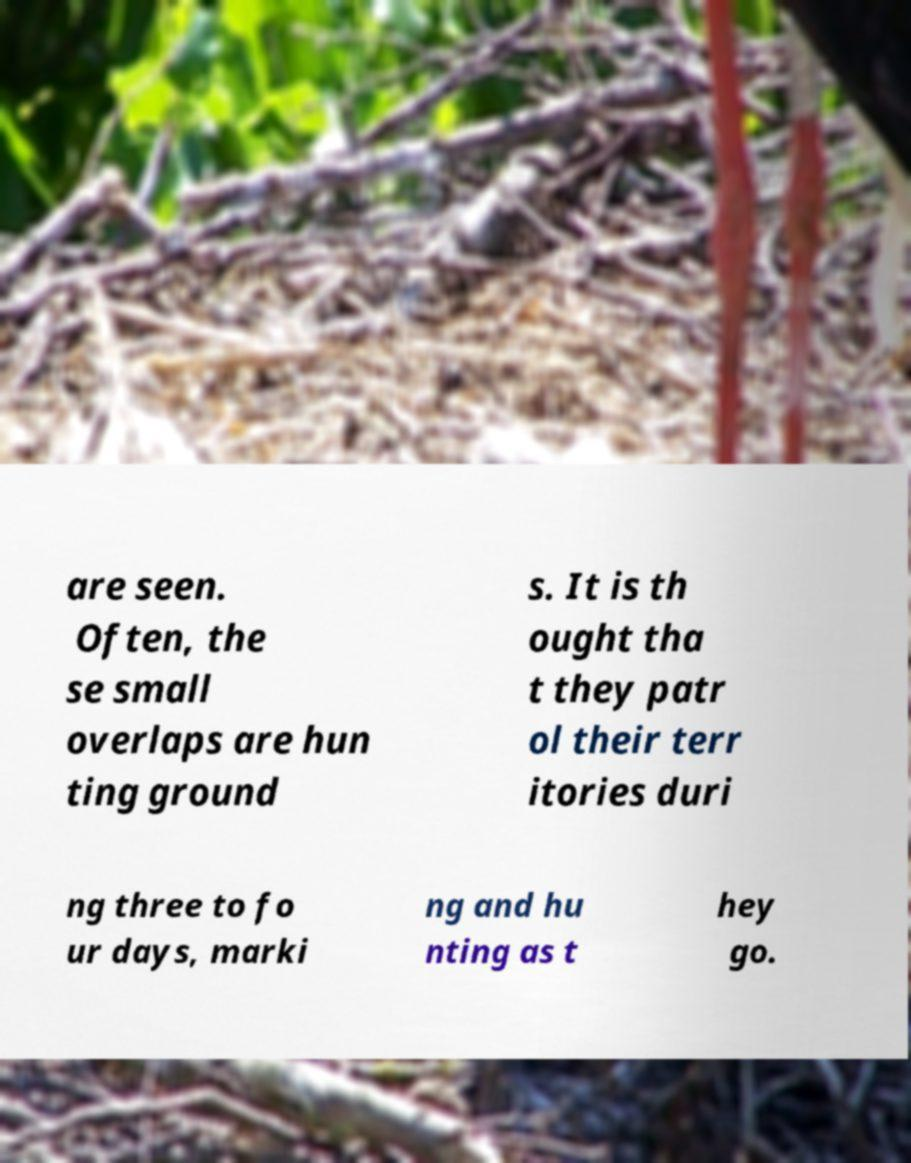Please identify and transcribe the text found in this image. are seen. Often, the se small overlaps are hun ting ground s. It is th ought tha t they patr ol their terr itories duri ng three to fo ur days, marki ng and hu nting as t hey go. 